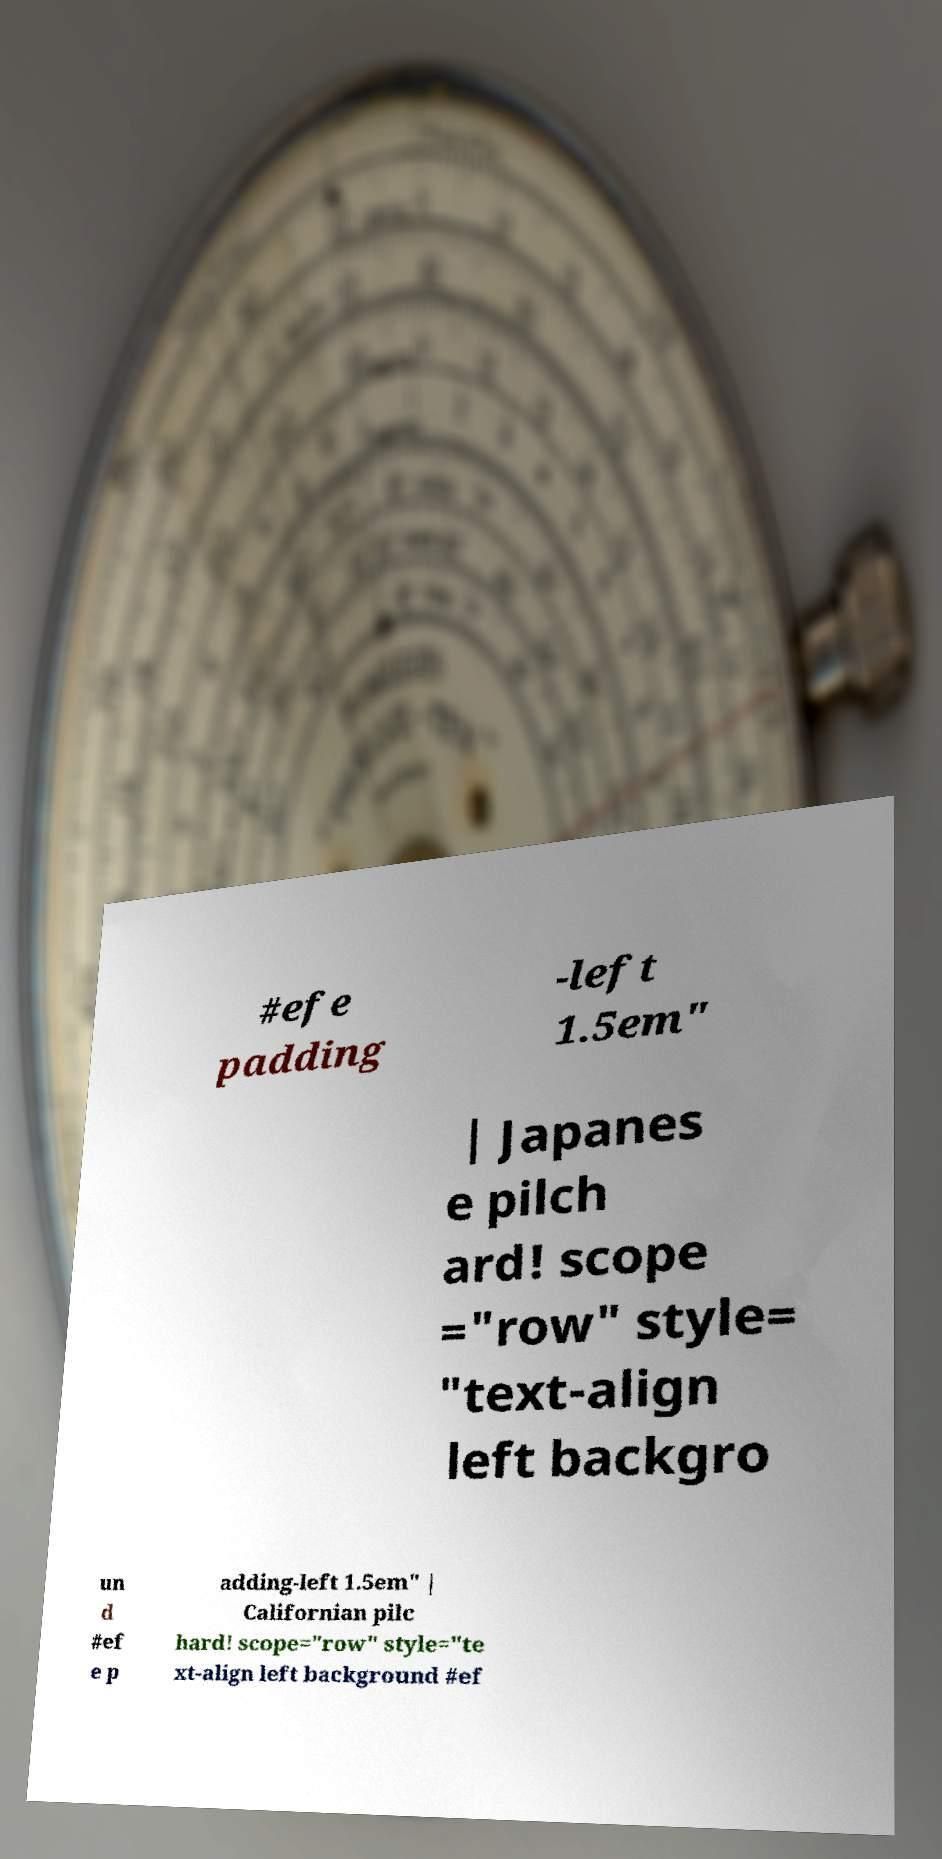Could you extract and type out the text from this image? #efe padding -left 1.5em" | Japanes e pilch ard! scope ="row" style= "text-align left backgro un d #ef e p adding-left 1.5em" | Californian pilc hard! scope="row" style="te xt-align left background #ef 